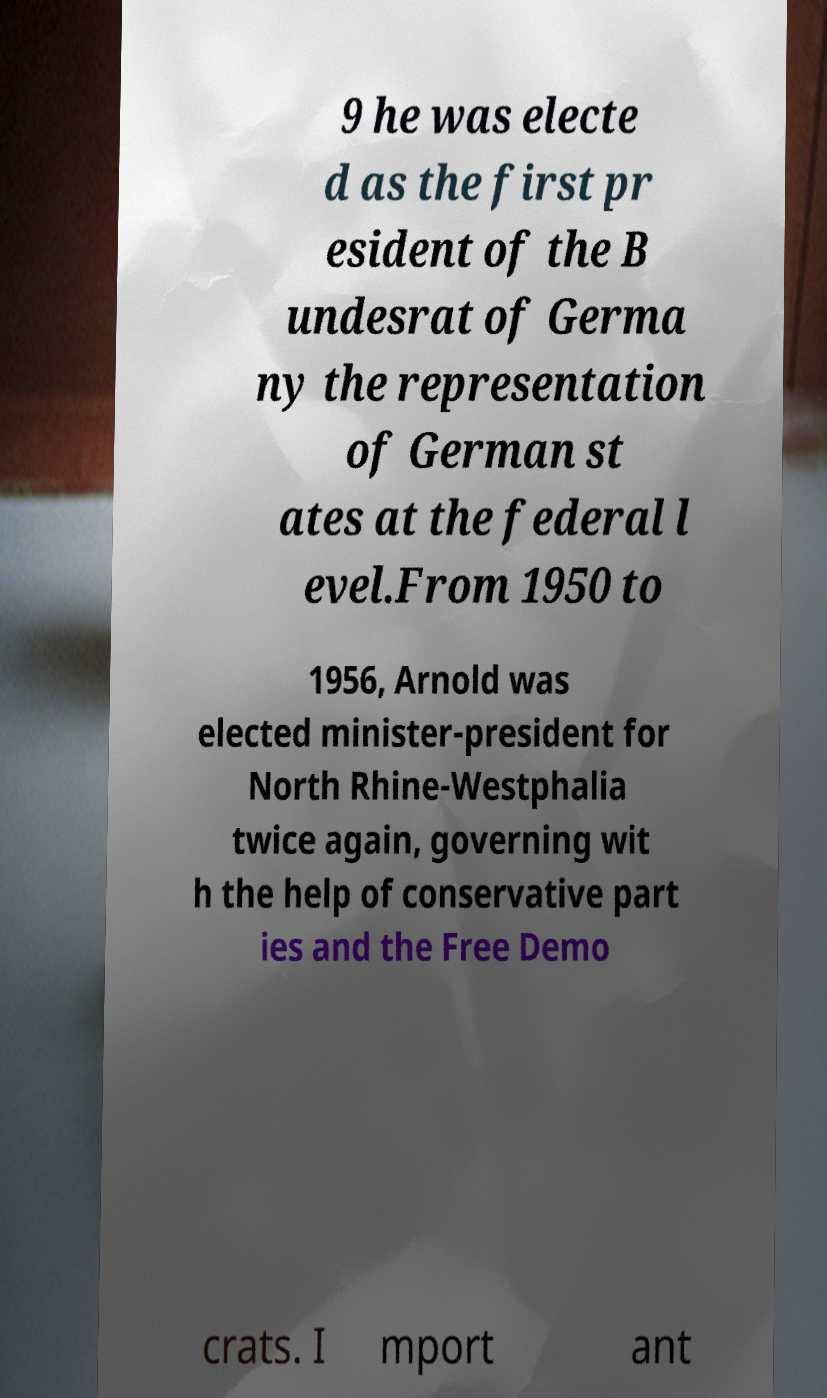There's text embedded in this image that I need extracted. Can you transcribe it verbatim? 9 he was electe d as the first pr esident of the B undesrat of Germa ny the representation of German st ates at the federal l evel.From 1950 to 1956, Arnold was elected minister-president for North Rhine-Westphalia twice again, governing wit h the help of conservative part ies and the Free Demo crats. I mport ant 